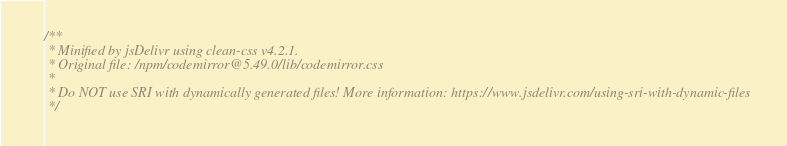<code> <loc_0><loc_0><loc_500><loc_500><_CSS_>/**
 * Minified by jsDelivr using clean-css v4.2.1.
 * Original file: /npm/codemirror@5.49.0/lib/codemirror.css
 * 
 * Do NOT use SRI with dynamically generated files! More information: https://www.jsdelivr.com/using-sri-with-dynamic-files
 */</code> 